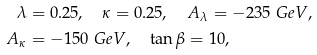Convert formula to latex. <formula><loc_0><loc_0><loc_500><loc_500>\lambda & = 0 . 2 5 , \quad \kappa = 0 . 2 5 , \quad A _ { \lambda } = - 2 3 5 \ G e V , \\ A _ { \kappa } & = - 1 5 0 \ G e V , \quad \tan \beta = 1 0 ,</formula> 